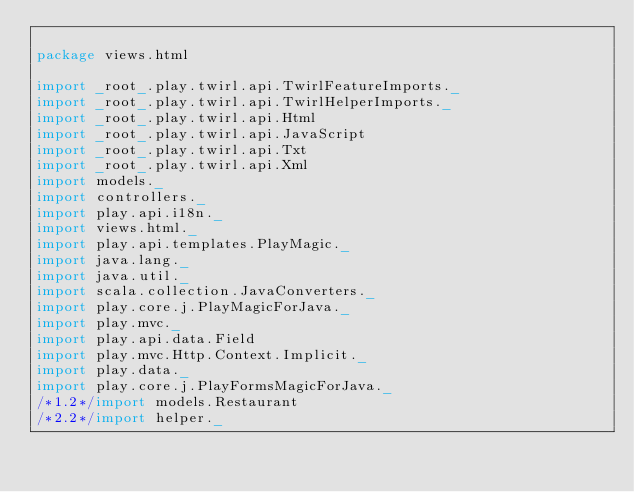<code> <loc_0><loc_0><loc_500><loc_500><_Scala_>
package views.html

import _root_.play.twirl.api.TwirlFeatureImports._
import _root_.play.twirl.api.TwirlHelperImports._
import _root_.play.twirl.api.Html
import _root_.play.twirl.api.JavaScript
import _root_.play.twirl.api.Txt
import _root_.play.twirl.api.Xml
import models._
import controllers._
import play.api.i18n._
import views.html._
import play.api.templates.PlayMagic._
import java.lang._
import java.util._
import scala.collection.JavaConverters._
import play.core.j.PlayMagicForJava._
import play.mvc._
import play.api.data.Field
import play.mvc.Http.Context.Implicit._
import play.data._
import play.core.j.PlayFormsMagicForJava._
/*1.2*/import models.Restaurant
/*2.2*/import helper._
</code> 